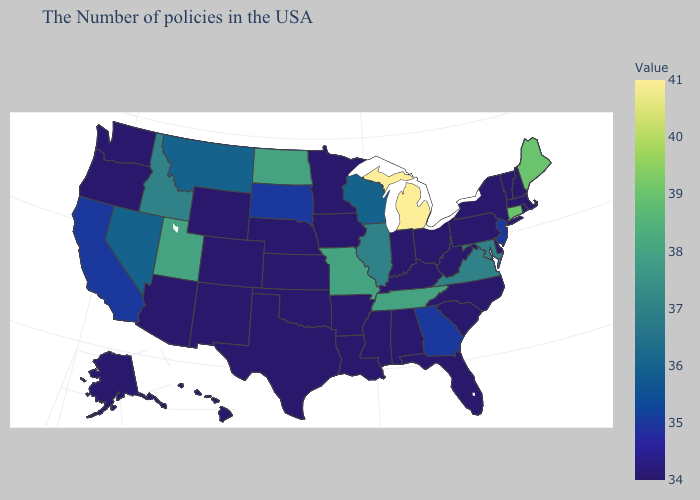Does Michigan have the highest value in the USA?
Concise answer only. Yes. Among the states that border West Virginia , does Ohio have the lowest value?
Short answer required. Yes. Which states have the lowest value in the USA?
Keep it brief. Massachusetts, Rhode Island, New Hampshire, Vermont, New York, Delaware, Pennsylvania, North Carolina, South Carolina, West Virginia, Ohio, Florida, Kentucky, Indiana, Alabama, Mississippi, Louisiana, Arkansas, Minnesota, Iowa, Kansas, Nebraska, Oklahoma, Texas, Wyoming, Colorado, New Mexico, Arizona, Washington, Oregon, Alaska, Hawaii. Among the states that border Arkansas , which have the highest value?
Keep it brief. Tennessee, Missouri. Does California have the lowest value in the USA?
Be succinct. No. 